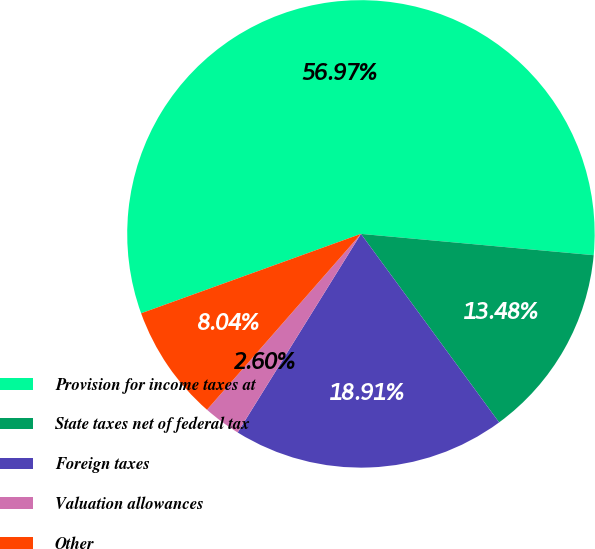Convert chart to OTSL. <chart><loc_0><loc_0><loc_500><loc_500><pie_chart><fcel>Provision for income taxes at<fcel>State taxes net of federal tax<fcel>Foreign taxes<fcel>Valuation allowances<fcel>Other<nl><fcel>56.97%<fcel>13.48%<fcel>18.91%<fcel>2.6%<fcel>8.04%<nl></chart> 